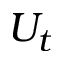Convert formula to latex. <formula><loc_0><loc_0><loc_500><loc_500>U _ { t }</formula> 